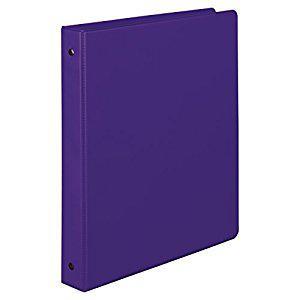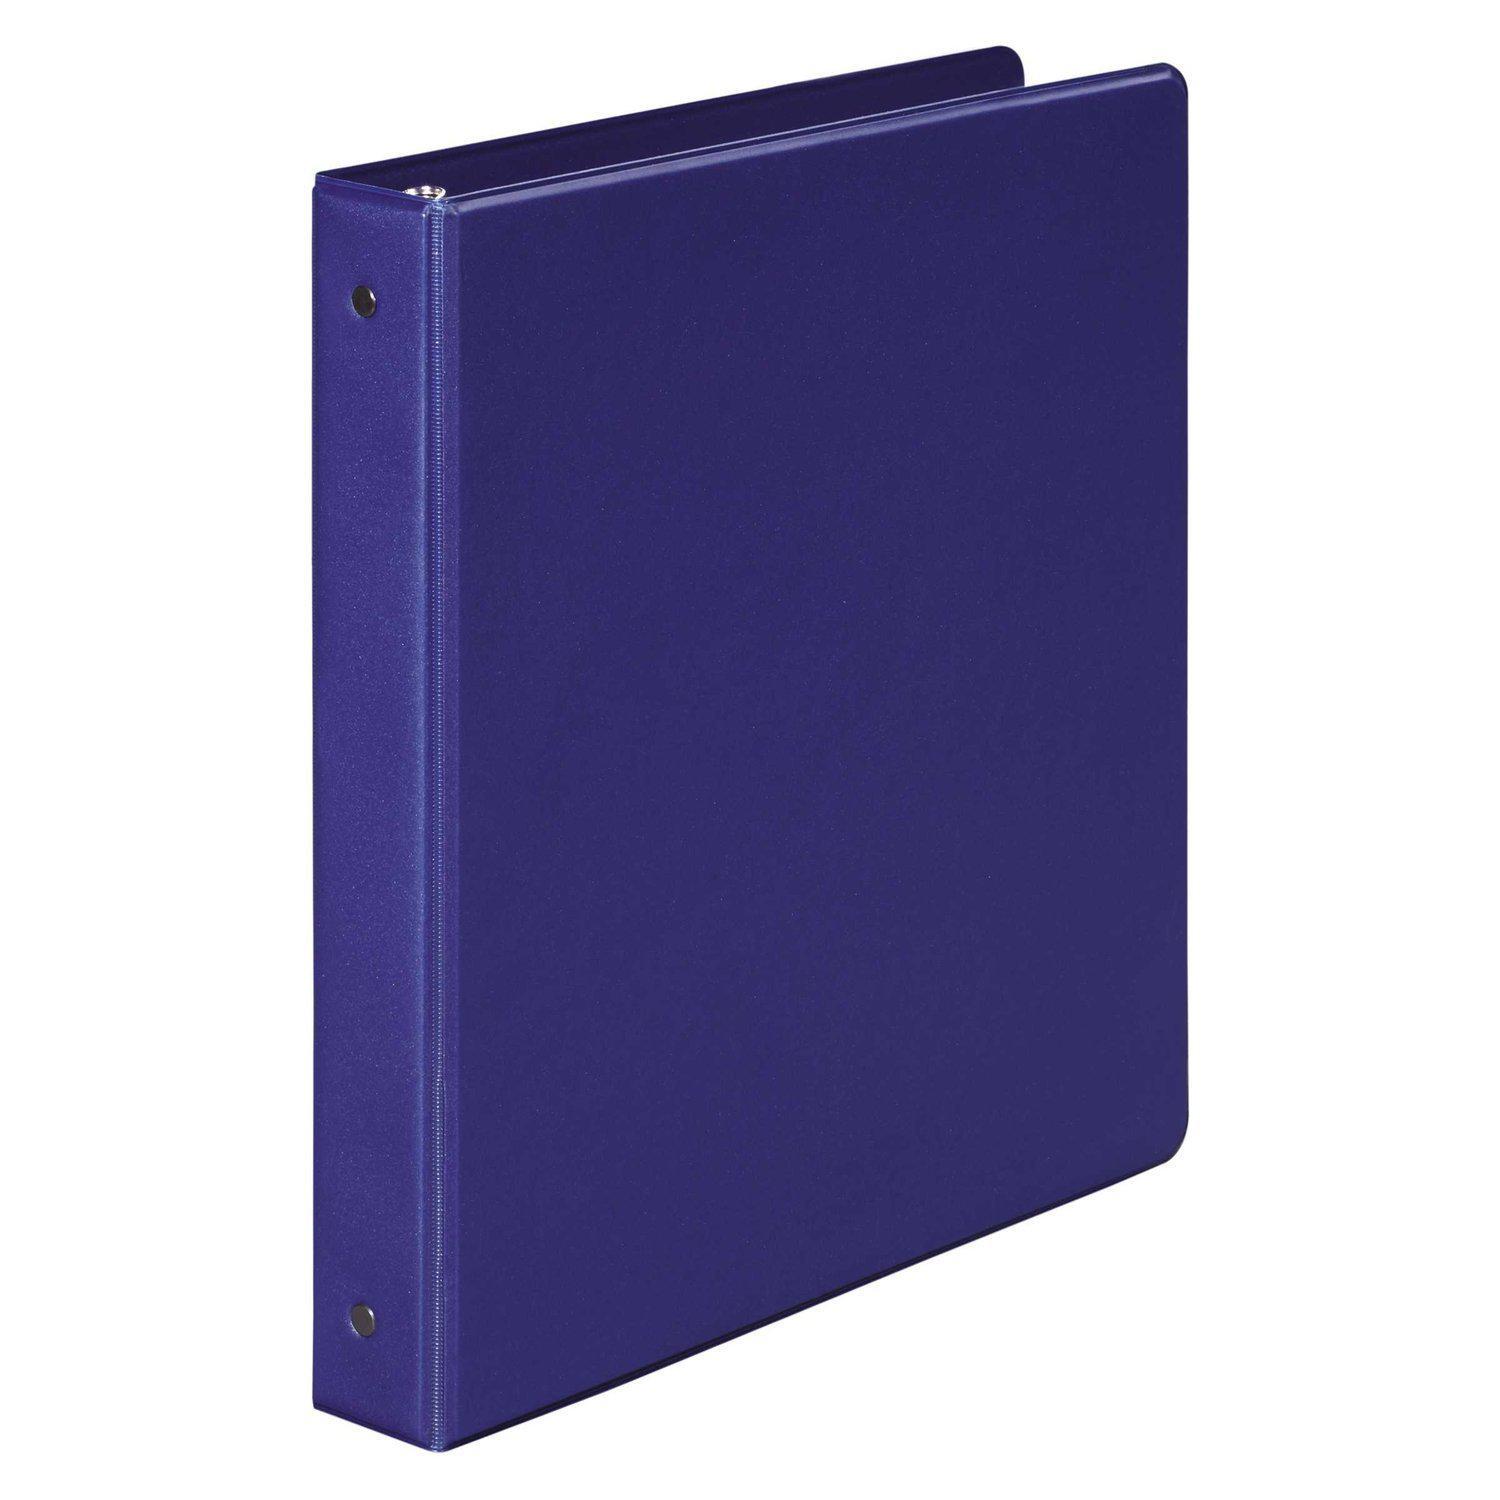The first image is the image on the left, the second image is the image on the right. Examine the images to the left and right. Is the description "Both binders are purple." accurate? Answer yes or no. Yes. The first image is the image on the left, the second image is the image on the right. For the images shown, is this caption "Two solid purple binder notebooks are shown in a similar stance, on end with the opening to the back, and have no visible contents." true? Answer yes or no. Yes. 